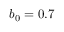<formula> <loc_0><loc_0><loc_500><loc_500>b _ { 0 } = 0 . 7</formula> 